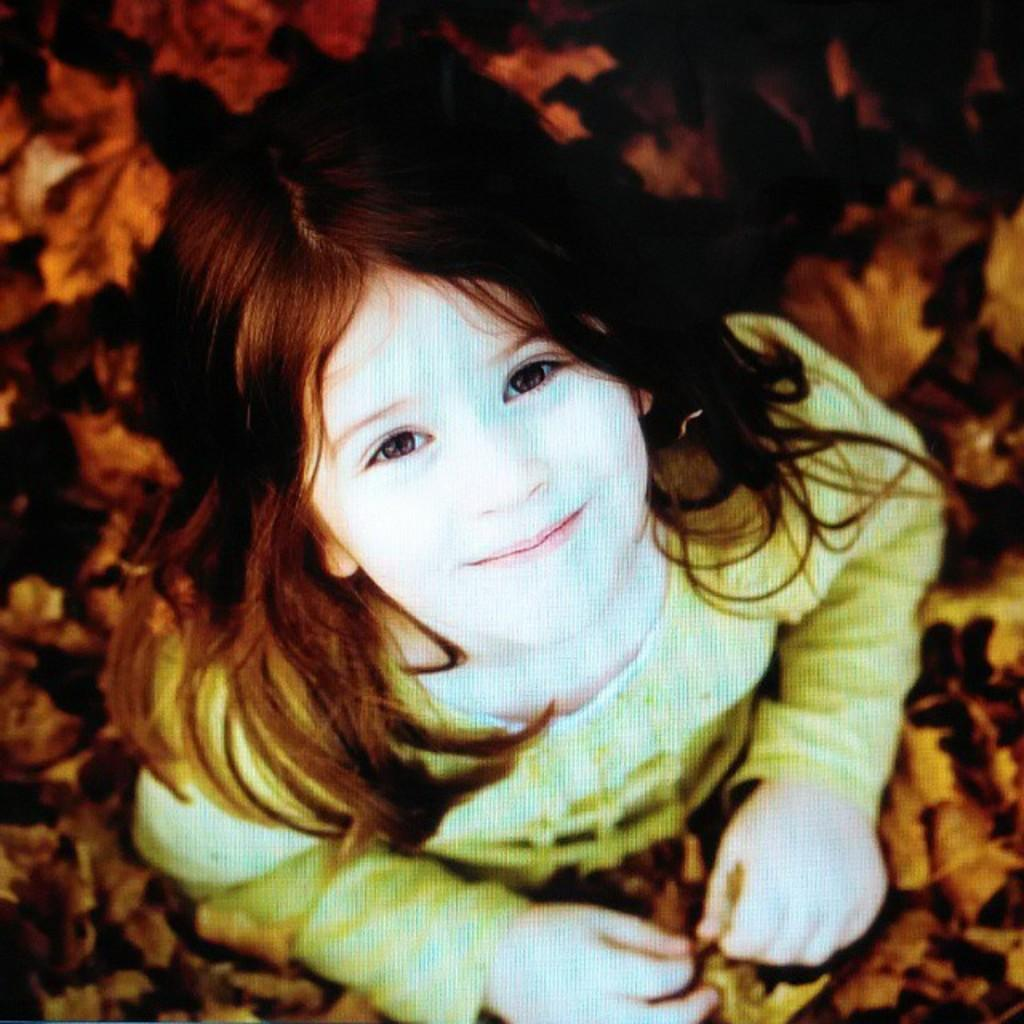Who is the main subject in the image? There is a girl in the image. What is the girl doing in the image? The girl is watching and smiling in the image. What can be seen in the background of the image? There are leaves visible in the image. What type of visual medium is the image? The image appears to be a poster. What type of loaf is the girl holding in the image? There is no loaf present in the image. Can you tell me where the girl is playing in the image? The image does not depict the girl playing; she is watching and smiling. 